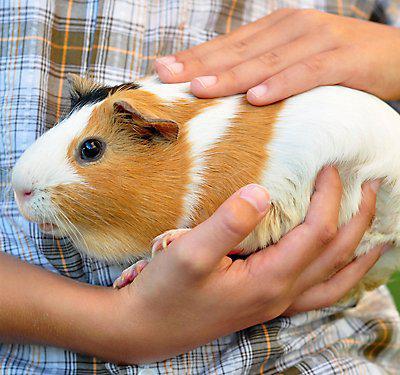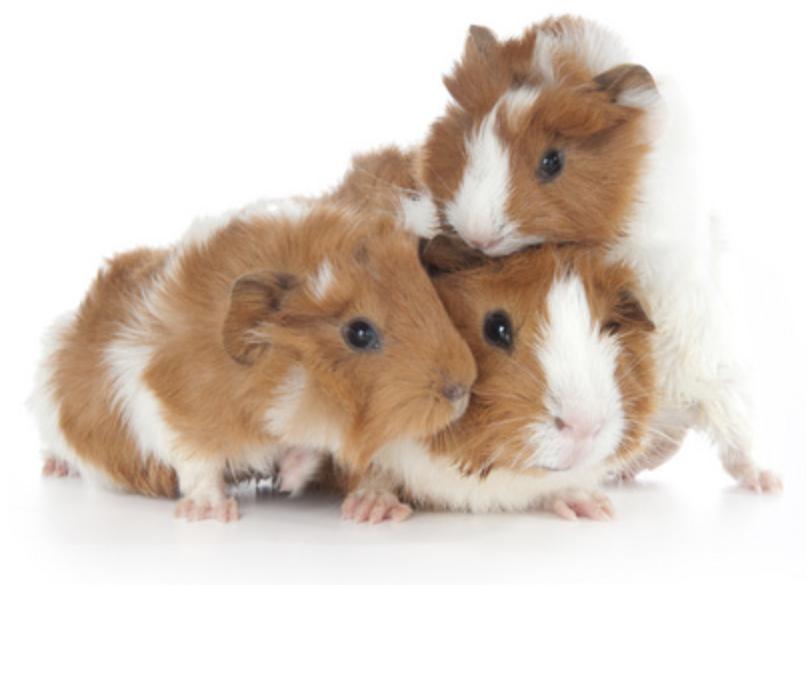The first image is the image on the left, the second image is the image on the right. Given the left and right images, does the statement "The right image contains at least two guinea pigs." hold true? Answer yes or no. Yes. The first image is the image on the left, the second image is the image on the right. Assess this claim about the two images: "The right image contains at least twice as many guinea pigs as the left image.". Correct or not? Answer yes or no. Yes. 